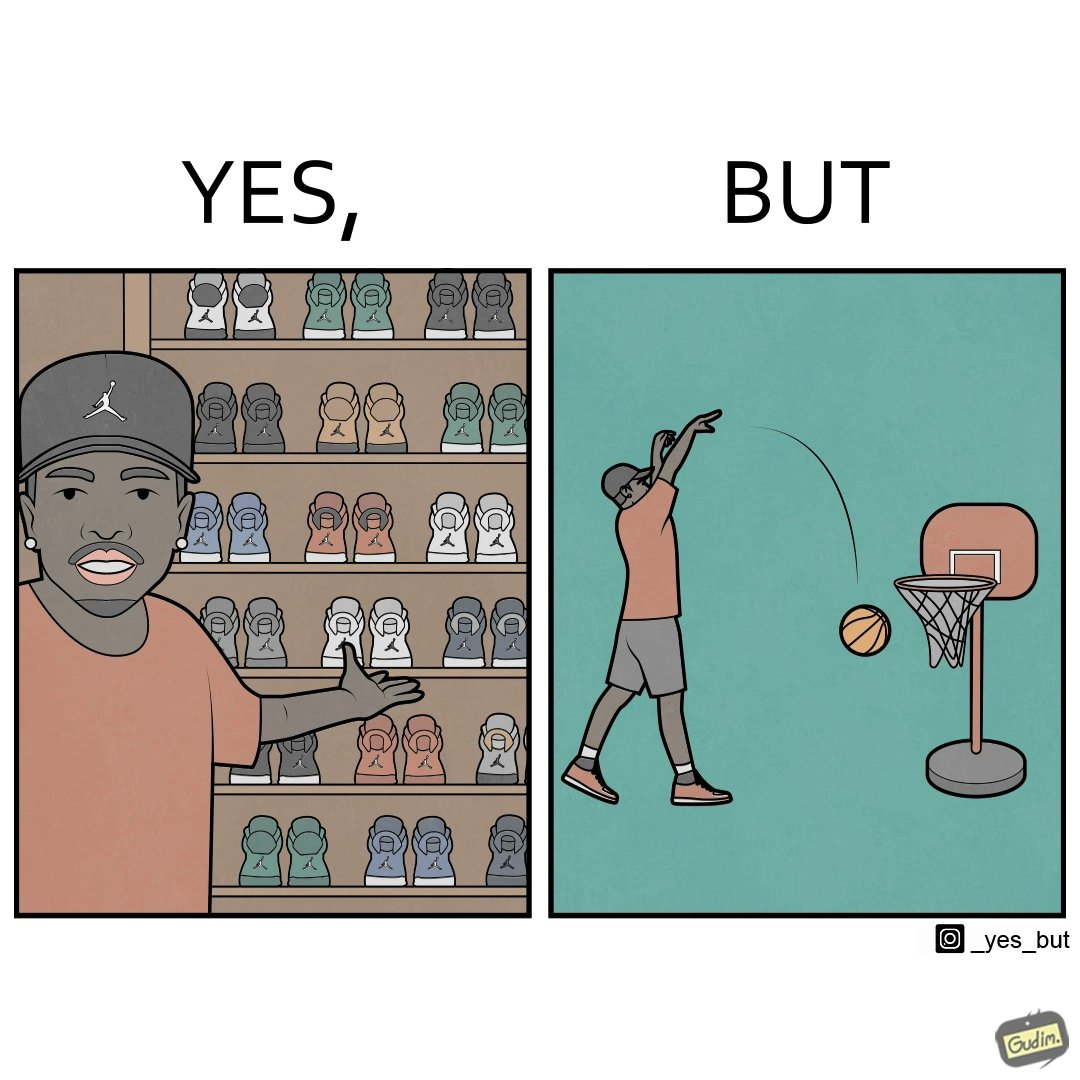What is the satirical meaning behind this image? The image is ironic, because even when the person has a large collection of shoes even then he is not able to basket a ball in a small height net 